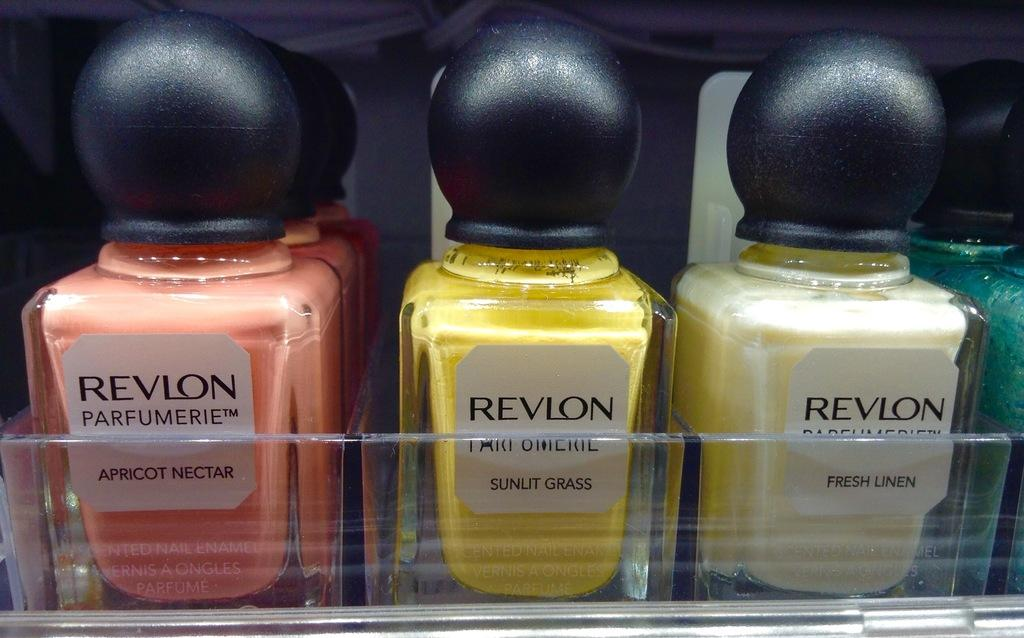What type of products are displayed in the image? There are bottles of perfumes in the image. Can you describe the appearance of the perfume bottles? The appearance of the perfume bottles is not mentioned in the provided facts, so we cannot describe them. How many perfume bottles are visible in the image? The number of perfume bottles is not mentioned in the provided facts, so we cannot determine the exact number. What type of authority does the porter have in the image? There is no porter present in the image, so we cannot determine the type of authority they might have. 